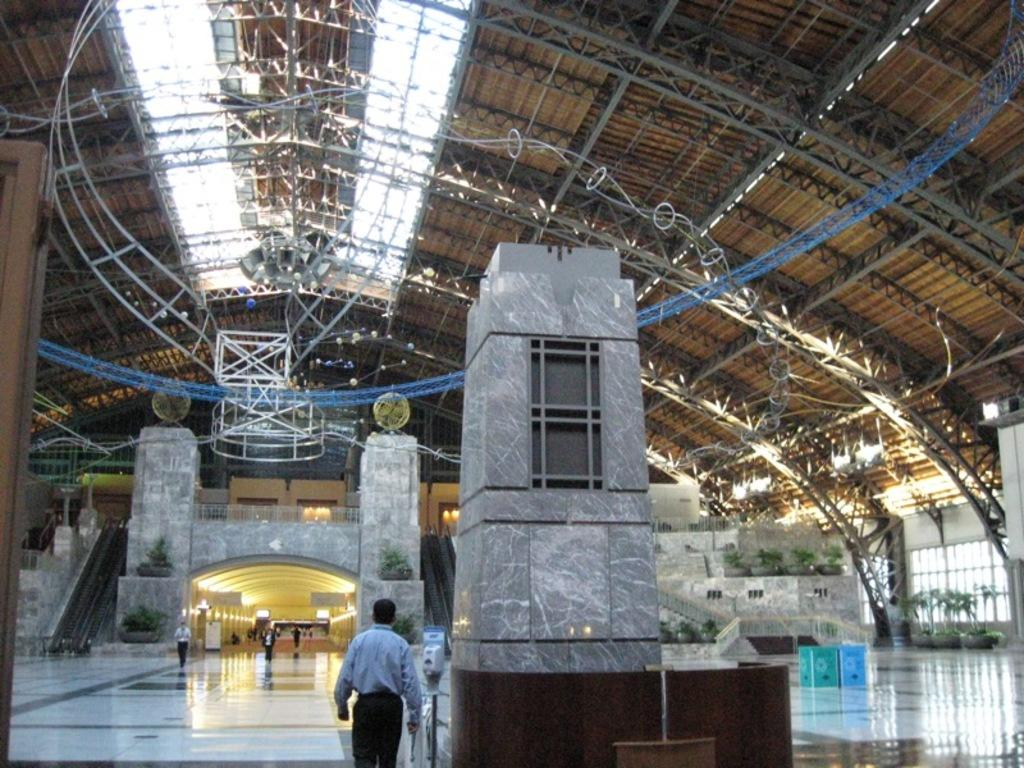What are the people in the image doing? The persons walking in the foreground of the image are walking. What can be seen in the middle of the image? There are steps and plants in the middle of the image. What is visible at the top of the image? There is a roof visible at the top of the image. Can you see any water in the image? There is no water visible in the image. Are there any stars in the image? There are no stars present in the image. 